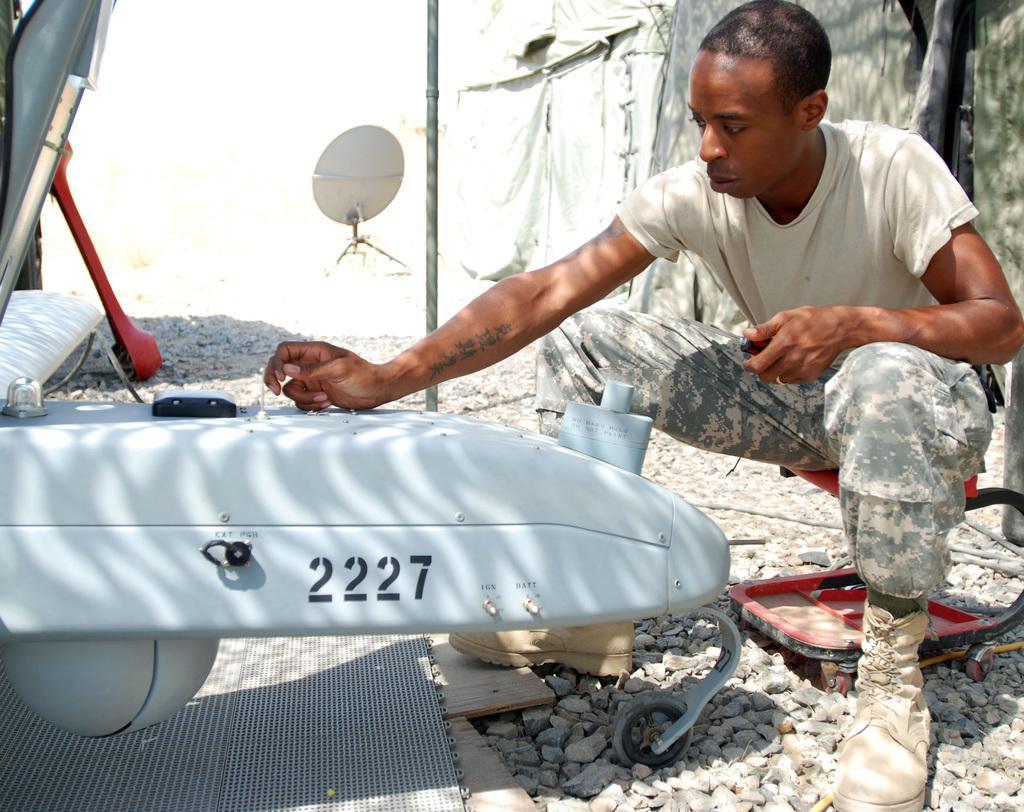Describe this image in one or two sentences. In this image I can see a person sitting wearing white color shirt, in front I can see an aircraft in white color. Background I can see a pole and few stones. 